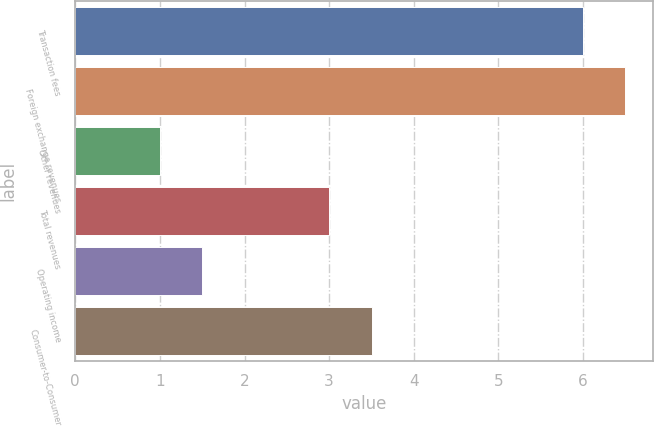Convert chart to OTSL. <chart><loc_0><loc_0><loc_500><loc_500><bar_chart><fcel>Transaction fees<fcel>Foreign exchange revenues<fcel>Other revenues<fcel>Total revenues<fcel>Operating income<fcel>Consumer-to-Consumer<nl><fcel>6<fcel>6.5<fcel>1<fcel>3<fcel>1.5<fcel>3.5<nl></chart> 